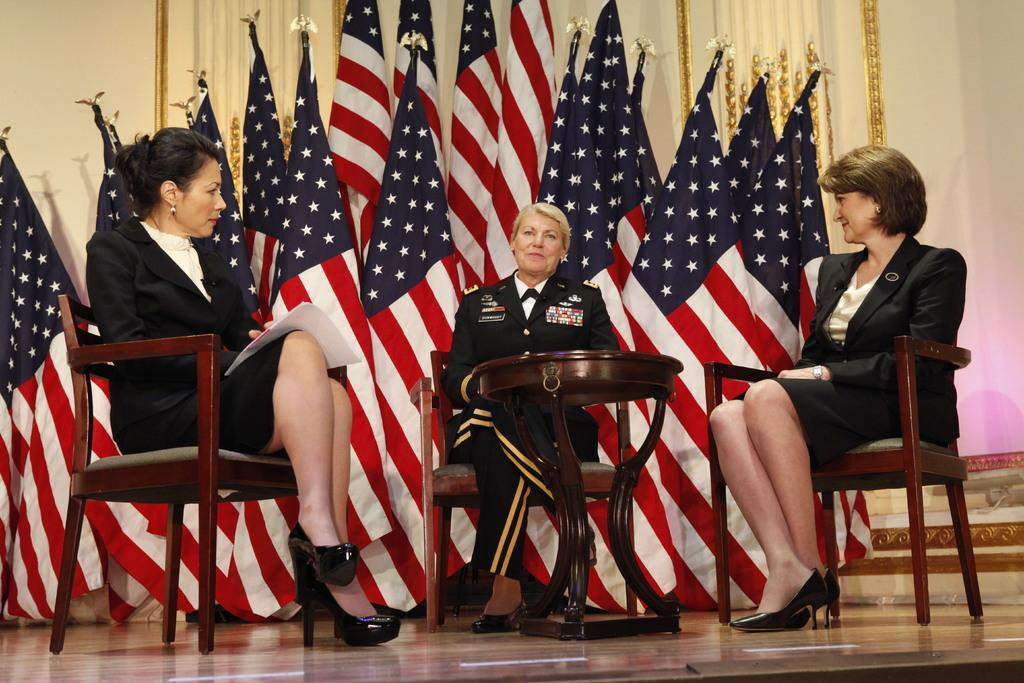How many ladies are present in the image? There are three ladies in the image. What are the ladies wearing? The ladies are wearing black jackets. What are the ladies doing in the image? The ladies are sitting on chairs. What is in the middle of the image? There is a table in the middle of the image. What can be seen in the background of the image? Many flags are visible in the background. What type of coach can be seen in the image? There is no coach present in the image. Are the ladies smiling in the image? The provided facts do not mention the ladies' facial expressions, so we cannot determine if they are smiling or not. 